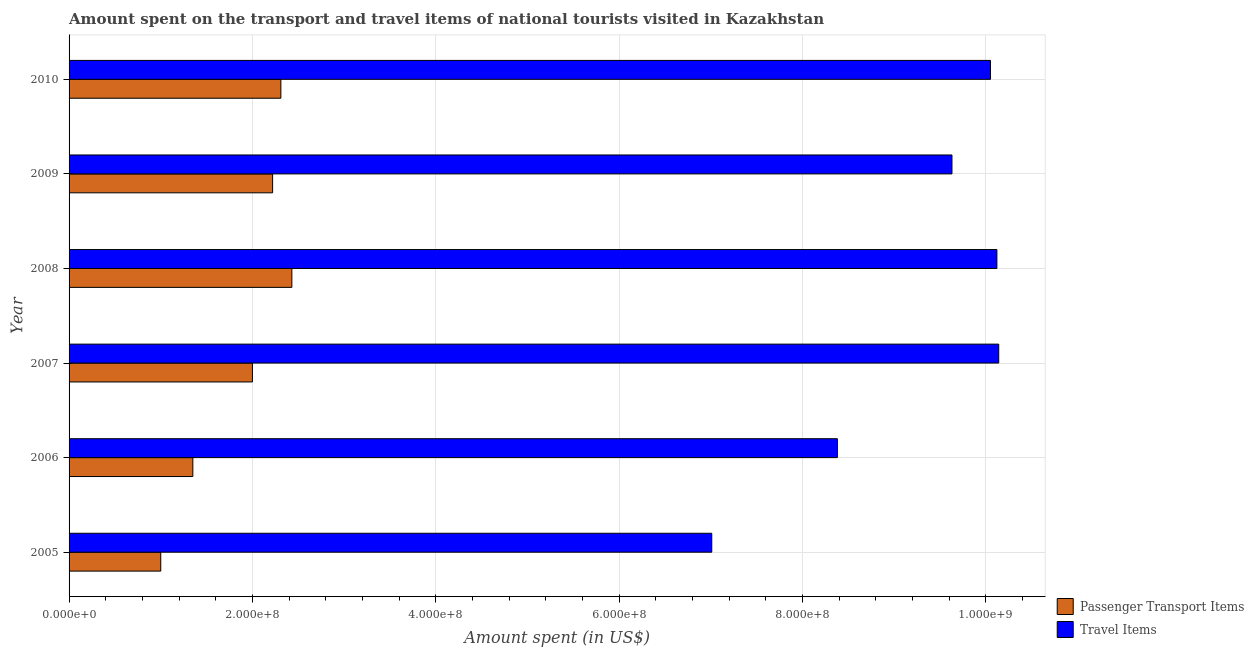Are the number of bars per tick equal to the number of legend labels?
Make the answer very short. Yes. How many bars are there on the 4th tick from the bottom?
Offer a terse response. 2. In how many cases, is the number of bars for a given year not equal to the number of legend labels?
Your response must be concise. 0. What is the amount spent on passenger transport items in 2005?
Provide a succinct answer. 1.00e+08. Across all years, what is the maximum amount spent in travel items?
Make the answer very short. 1.01e+09. Across all years, what is the minimum amount spent in travel items?
Your answer should be compact. 7.01e+08. In which year was the amount spent on passenger transport items minimum?
Make the answer very short. 2005. What is the total amount spent in travel items in the graph?
Keep it short and to the point. 5.53e+09. What is the difference between the amount spent on passenger transport items in 2006 and that in 2008?
Provide a short and direct response. -1.08e+08. What is the difference between the amount spent in travel items in 2008 and the amount spent on passenger transport items in 2007?
Your answer should be very brief. 8.12e+08. What is the average amount spent in travel items per year?
Offer a terse response. 9.22e+08. In the year 2007, what is the difference between the amount spent in travel items and amount spent on passenger transport items?
Your response must be concise. 8.14e+08. What is the ratio of the amount spent in travel items in 2005 to that in 2008?
Make the answer very short. 0.69. Is the amount spent in travel items in 2008 less than that in 2010?
Ensure brevity in your answer.  No. What is the difference between the highest and the lowest amount spent in travel items?
Provide a succinct answer. 3.13e+08. In how many years, is the amount spent on passenger transport items greater than the average amount spent on passenger transport items taken over all years?
Give a very brief answer. 4. What does the 2nd bar from the top in 2007 represents?
Keep it short and to the point. Passenger Transport Items. What does the 2nd bar from the bottom in 2010 represents?
Your response must be concise. Travel Items. How many bars are there?
Your answer should be very brief. 12. Are all the bars in the graph horizontal?
Your answer should be very brief. Yes. Are the values on the major ticks of X-axis written in scientific E-notation?
Your answer should be compact. Yes. Does the graph contain any zero values?
Keep it short and to the point. No. What is the title of the graph?
Offer a terse response. Amount spent on the transport and travel items of national tourists visited in Kazakhstan. What is the label or title of the X-axis?
Your answer should be compact. Amount spent (in US$). What is the label or title of the Y-axis?
Offer a terse response. Year. What is the Amount spent (in US$) in Passenger Transport Items in 2005?
Provide a succinct answer. 1.00e+08. What is the Amount spent (in US$) of Travel Items in 2005?
Ensure brevity in your answer.  7.01e+08. What is the Amount spent (in US$) of Passenger Transport Items in 2006?
Provide a short and direct response. 1.35e+08. What is the Amount spent (in US$) in Travel Items in 2006?
Provide a succinct answer. 8.38e+08. What is the Amount spent (in US$) in Travel Items in 2007?
Make the answer very short. 1.01e+09. What is the Amount spent (in US$) of Passenger Transport Items in 2008?
Ensure brevity in your answer.  2.43e+08. What is the Amount spent (in US$) in Travel Items in 2008?
Give a very brief answer. 1.01e+09. What is the Amount spent (in US$) in Passenger Transport Items in 2009?
Provide a short and direct response. 2.22e+08. What is the Amount spent (in US$) in Travel Items in 2009?
Give a very brief answer. 9.63e+08. What is the Amount spent (in US$) in Passenger Transport Items in 2010?
Provide a succinct answer. 2.31e+08. What is the Amount spent (in US$) of Travel Items in 2010?
Give a very brief answer. 1.00e+09. Across all years, what is the maximum Amount spent (in US$) in Passenger Transport Items?
Provide a succinct answer. 2.43e+08. Across all years, what is the maximum Amount spent (in US$) in Travel Items?
Your answer should be compact. 1.01e+09. Across all years, what is the minimum Amount spent (in US$) of Passenger Transport Items?
Provide a succinct answer. 1.00e+08. Across all years, what is the minimum Amount spent (in US$) in Travel Items?
Your response must be concise. 7.01e+08. What is the total Amount spent (in US$) in Passenger Transport Items in the graph?
Your response must be concise. 1.13e+09. What is the total Amount spent (in US$) in Travel Items in the graph?
Offer a terse response. 5.53e+09. What is the difference between the Amount spent (in US$) in Passenger Transport Items in 2005 and that in 2006?
Provide a short and direct response. -3.50e+07. What is the difference between the Amount spent (in US$) of Travel Items in 2005 and that in 2006?
Your response must be concise. -1.37e+08. What is the difference between the Amount spent (in US$) in Passenger Transport Items in 2005 and that in 2007?
Keep it short and to the point. -1.00e+08. What is the difference between the Amount spent (in US$) in Travel Items in 2005 and that in 2007?
Keep it short and to the point. -3.13e+08. What is the difference between the Amount spent (in US$) of Passenger Transport Items in 2005 and that in 2008?
Your answer should be compact. -1.43e+08. What is the difference between the Amount spent (in US$) of Travel Items in 2005 and that in 2008?
Offer a terse response. -3.11e+08. What is the difference between the Amount spent (in US$) in Passenger Transport Items in 2005 and that in 2009?
Your response must be concise. -1.22e+08. What is the difference between the Amount spent (in US$) of Travel Items in 2005 and that in 2009?
Offer a very short reply. -2.62e+08. What is the difference between the Amount spent (in US$) in Passenger Transport Items in 2005 and that in 2010?
Ensure brevity in your answer.  -1.31e+08. What is the difference between the Amount spent (in US$) in Travel Items in 2005 and that in 2010?
Ensure brevity in your answer.  -3.04e+08. What is the difference between the Amount spent (in US$) in Passenger Transport Items in 2006 and that in 2007?
Offer a terse response. -6.50e+07. What is the difference between the Amount spent (in US$) in Travel Items in 2006 and that in 2007?
Your response must be concise. -1.76e+08. What is the difference between the Amount spent (in US$) of Passenger Transport Items in 2006 and that in 2008?
Make the answer very short. -1.08e+08. What is the difference between the Amount spent (in US$) of Travel Items in 2006 and that in 2008?
Your answer should be compact. -1.74e+08. What is the difference between the Amount spent (in US$) of Passenger Transport Items in 2006 and that in 2009?
Offer a very short reply. -8.70e+07. What is the difference between the Amount spent (in US$) of Travel Items in 2006 and that in 2009?
Give a very brief answer. -1.25e+08. What is the difference between the Amount spent (in US$) in Passenger Transport Items in 2006 and that in 2010?
Ensure brevity in your answer.  -9.60e+07. What is the difference between the Amount spent (in US$) in Travel Items in 2006 and that in 2010?
Keep it short and to the point. -1.67e+08. What is the difference between the Amount spent (in US$) in Passenger Transport Items in 2007 and that in 2008?
Keep it short and to the point. -4.30e+07. What is the difference between the Amount spent (in US$) in Travel Items in 2007 and that in 2008?
Give a very brief answer. 2.00e+06. What is the difference between the Amount spent (in US$) of Passenger Transport Items in 2007 and that in 2009?
Offer a terse response. -2.20e+07. What is the difference between the Amount spent (in US$) of Travel Items in 2007 and that in 2009?
Your answer should be compact. 5.10e+07. What is the difference between the Amount spent (in US$) in Passenger Transport Items in 2007 and that in 2010?
Make the answer very short. -3.10e+07. What is the difference between the Amount spent (in US$) of Travel Items in 2007 and that in 2010?
Your answer should be compact. 9.00e+06. What is the difference between the Amount spent (in US$) in Passenger Transport Items in 2008 and that in 2009?
Give a very brief answer. 2.10e+07. What is the difference between the Amount spent (in US$) of Travel Items in 2008 and that in 2009?
Your answer should be very brief. 4.90e+07. What is the difference between the Amount spent (in US$) of Passenger Transport Items in 2008 and that in 2010?
Your answer should be compact. 1.20e+07. What is the difference between the Amount spent (in US$) in Travel Items in 2008 and that in 2010?
Offer a terse response. 7.00e+06. What is the difference between the Amount spent (in US$) of Passenger Transport Items in 2009 and that in 2010?
Your response must be concise. -9.00e+06. What is the difference between the Amount spent (in US$) of Travel Items in 2009 and that in 2010?
Your response must be concise. -4.20e+07. What is the difference between the Amount spent (in US$) of Passenger Transport Items in 2005 and the Amount spent (in US$) of Travel Items in 2006?
Give a very brief answer. -7.38e+08. What is the difference between the Amount spent (in US$) in Passenger Transport Items in 2005 and the Amount spent (in US$) in Travel Items in 2007?
Ensure brevity in your answer.  -9.14e+08. What is the difference between the Amount spent (in US$) in Passenger Transport Items in 2005 and the Amount spent (in US$) in Travel Items in 2008?
Offer a very short reply. -9.12e+08. What is the difference between the Amount spent (in US$) in Passenger Transport Items in 2005 and the Amount spent (in US$) in Travel Items in 2009?
Your answer should be very brief. -8.63e+08. What is the difference between the Amount spent (in US$) of Passenger Transport Items in 2005 and the Amount spent (in US$) of Travel Items in 2010?
Provide a succinct answer. -9.05e+08. What is the difference between the Amount spent (in US$) in Passenger Transport Items in 2006 and the Amount spent (in US$) in Travel Items in 2007?
Make the answer very short. -8.79e+08. What is the difference between the Amount spent (in US$) in Passenger Transport Items in 2006 and the Amount spent (in US$) in Travel Items in 2008?
Provide a short and direct response. -8.77e+08. What is the difference between the Amount spent (in US$) in Passenger Transport Items in 2006 and the Amount spent (in US$) in Travel Items in 2009?
Provide a short and direct response. -8.28e+08. What is the difference between the Amount spent (in US$) of Passenger Transport Items in 2006 and the Amount spent (in US$) of Travel Items in 2010?
Give a very brief answer. -8.70e+08. What is the difference between the Amount spent (in US$) in Passenger Transport Items in 2007 and the Amount spent (in US$) in Travel Items in 2008?
Offer a terse response. -8.12e+08. What is the difference between the Amount spent (in US$) in Passenger Transport Items in 2007 and the Amount spent (in US$) in Travel Items in 2009?
Make the answer very short. -7.63e+08. What is the difference between the Amount spent (in US$) of Passenger Transport Items in 2007 and the Amount spent (in US$) of Travel Items in 2010?
Your answer should be compact. -8.05e+08. What is the difference between the Amount spent (in US$) in Passenger Transport Items in 2008 and the Amount spent (in US$) in Travel Items in 2009?
Make the answer very short. -7.20e+08. What is the difference between the Amount spent (in US$) of Passenger Transport Items in 2008 and the Amount spent (in US$) of Travel Items in 2010?
Provide a short and direct response. -7.62e+08. What is the difference between the Amount spent (in US$) in Passenger Transport Items in 2009 and the Amount spent (in US$) in Travel Items in 2010?
Give a very brief answer. -7.83e+08. What is the average Amount spent (in US$) of Passenger Transport Items per year?
Your response must be concise. 1.88e+08. What is the average Amount spent (in US$) in Travel Items per year?
Offer a terse response. 9.22e+08. In the year 2005, what is the difference between the Amount spent (in US$) in Passenger Transport Items and Amount spent (in US$) in Travel Items?
Your answer should be very brief. -6.01e+08. In the year 2006, what is the difference between the Amount spent (in US$) in Passenger Transport Items and Amount spent (in US$) in Travel Items?
Make the answer very short. -7.03e+08. In the year 2007, what is the difference between the Amount spent (in US$) in Passenger Transport Items and Amount spent (in US$) in Travel Items?
Give a very brief answer. -8.14e+08. In the year 2008, what is the difference between the Amount spent (in US$) in Passenger Transport Items and Amount spent (in US$) in Travel Items?
Give a very brief answer. -7.69e+08. In the year 2009, what is the difference between the Amount spent (in US$) in Passenger Transport Items and Amount spent (in US$) in Travel Items?
Make the answer very short. -7.41e+08. In the year 2010, what is the difference between the Amount spent (in US$) in Passenger Transport Items and Amount spent (in US$) in Travel Items?
Offer a very short reply. -7.74e+08. What is the ratio of the Amount spent (in US$) in Passenger Transport Items in 2005 to that in 2006?
Offer a very short reply. 0.74. What is the ratio of the Amount spent (in US$) of Travel Items in 2005 to that in 2006?
Your response must be concise. 0.84. What is the ratio of the Amount spent (in US$) in Travel Items in 2005 to that in 2007?
Offer a very short reply. 0.69. What is the ratio of the Amount spent (in US$) in Passenger Transport Items in 2005 to that in 2008?
Give a very brief answer. 0.41. What is the ratio of the Amount spent (in US$) in Travel Items in 2005 to that in 2008?
Your answer should be very brief. 0.69. What is the ratio of the Amount spent (in US$) in Passenger Transport Items in 2005 to that in 2009?
Ensure brevity in your answer.  0.45. What is the ratio of the Amount spent (in US$) of Travel Items in 2005 to that in 2009?
Provide a succinct answer. 0.73. What is the ratio of the Amount spent (in US$) in Passenger Transport Items in 2005 to that in 2010?
Keep it short and to the point. 0.43. What is the ratio of the Amount spent (in US$) in Travel Items in 2005 to that in 2010?
Your answer should be compact. 0.7. What is the ratio of the Amount spent (in US$) in Passenger Transport Items in 2006 to that in 2007?
Make the answer very short. 0.68. What is the ratio of the Amount spent (in US$) in Travel Items in 2006 to that in 2007?
Give a very brief answer. 0.83. What is the ratio of the Amount spent (in US$) in Passenger Transport Items in 2006 to that in 2008?
Offer a terse response. 0.56. What is the ratio of the Amount spent (in US$) in Travel Items in 2006 to that in 2008?
Give a very brief answer. 0.83. What is the ratio of the Amount spent (in US$) of Passenger Transport Items in 2006 to that in 2009?
Keep it short and to the point. 0.61. What is the ratio of the Amount spent (in US$) of Travel Items in 2006 to that in 2009?
Give a very brief answer. 0.87. What is the ratio of the Amount spent (in US$) in Passenger Transport Items in 2006 to that in 2010?
Your answer should be compact. 0.58. What is the ratio of the Amount spent (in US$) of Travel Items in 2006 to that in 2010?
Keep it short and to the point. 0.83. What is the ratio of the Amount spent (in US$) in Passenger Transport Items in 2007 to that in 2008?
Your answer should be compact. 0.82. What is the ratio of the Amount spent (in US$) in Passenger Transport Items in 2007 to that in 2009?
Provide a succinct answer. 0.9. What is the ratio of the Amount spent (in US$) of Travel Items in 2007 to that in 2009?
Offer a terse response. 1.05. What is the ratio of the Amount spent (in US$) in Passenger Transport Items in 2007 to that in 2010?
Provide a short and direct response. 0.87. What is the ratio of the Amount spent (in US$) in Passenger Transport Items in 2008 to that in 2009?
Your answer should be very brief. 1.09. What is the ratio of the Amount spent (in US$) of Travel Items in 2008 to that in 2009?
Your answer should be compact. 1.05. What is the ratio of the Amount spent (in US$) of Passenger Transport Items in 2008 to that in 2010?
Your answer should be compact. 1.05. What is the ratio of the Amount spent (in US$) in Travel Items in 2008 to that in 2010?
Your response must be concise. 1.01. What is the ratio of the Amount spent (in US$) of Passenger Transport Items in 2009 to that in 2010?
Your answer should be compact. 0.96. What is the ratio of the Amount spent (in US$) of Travel Items in 2009 to that in 2010?
Ensure brevity in your answer.  0.96. What is the difference between the highest and the second highest Amount spent (in US$) in Travel Items?
Your response must be concise. 2.00e+06. What is the difference between the highest and the lowest Amount spent (in US$) in Passenger Transport Items?
Give a very brief answer. 1.43e+08. What is the difference between the highest and the lowest Amount spent (in US$) of Travel Items?
Your answer should be very brief. 3.13e+08. 